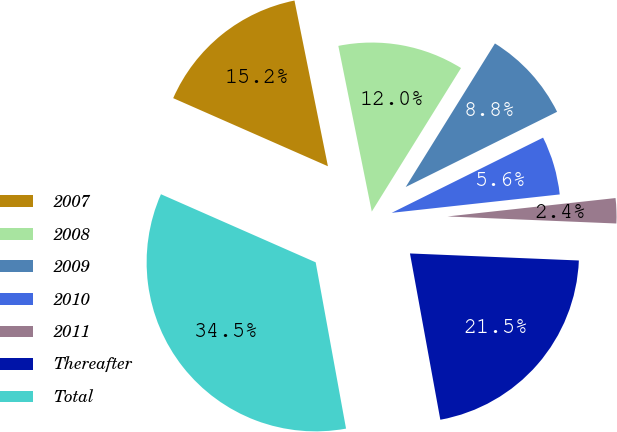Convert chart. <chart><loc_0><loc_0><loc_500><loc_500><pie_chart><fcel>2007<fcel>2008<fcel>2009<fcel>2010<fcel>2011<fcel>Thereafter<fcel>Total<nl><fcel>15.23%<fcel>12.02%<fcel>8.81%<fcel>5.6%<fcel>2.4%<fcel>21.46%<fcel>34.47%<nl></chart> 